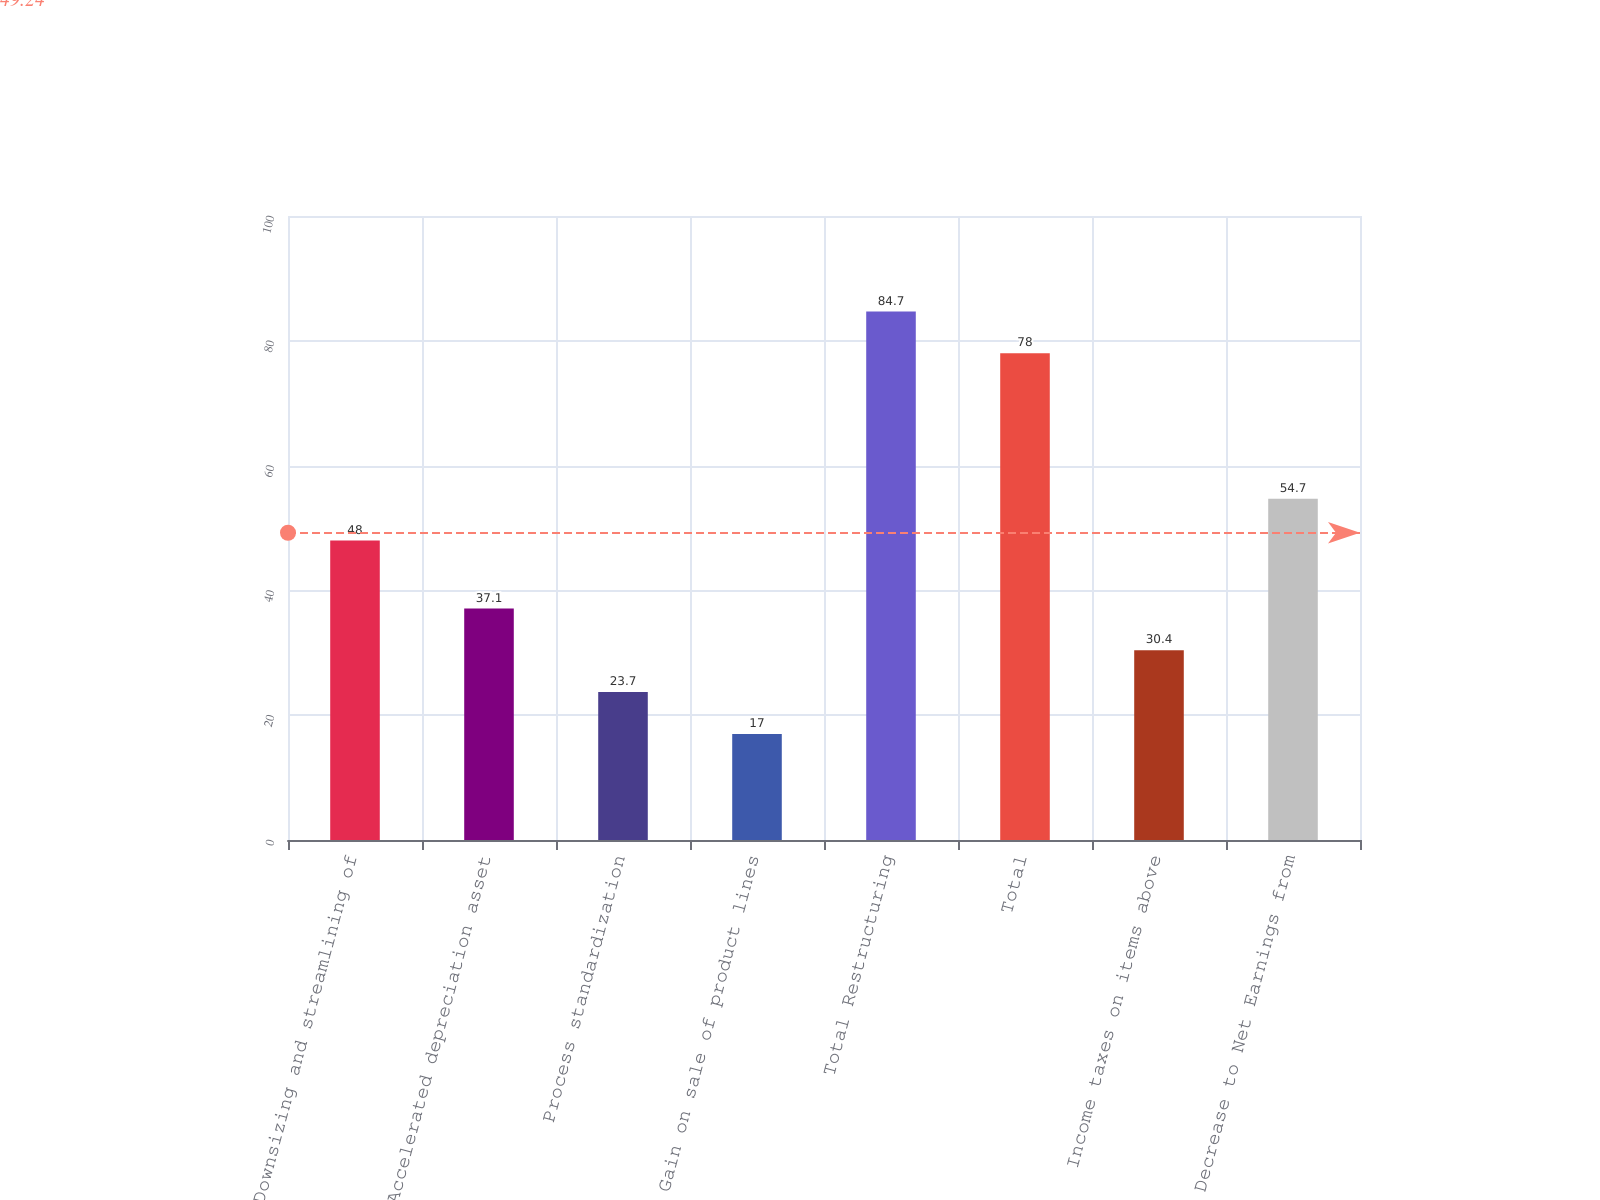Convert chart to OTSL. <chart><loc_0><loc_0><loc_500><loc_500><bar_chart><fcel>Downsizing and streamlining of<fcel>Accelerated depreciation asset<fcel>Process standardization<fcel>Gain on sale of product lines<fcel>Total Restructuring<fcel>Total<fcel>Income taxes on items above<fcel>Decrease to Net Earnings from<nl><fcel>48<fcel>37.1<fcel>23.7<fcel>17<fcel>84.7<fcel>78<fcel>30.4<fcel>54.7<nl></chart> 